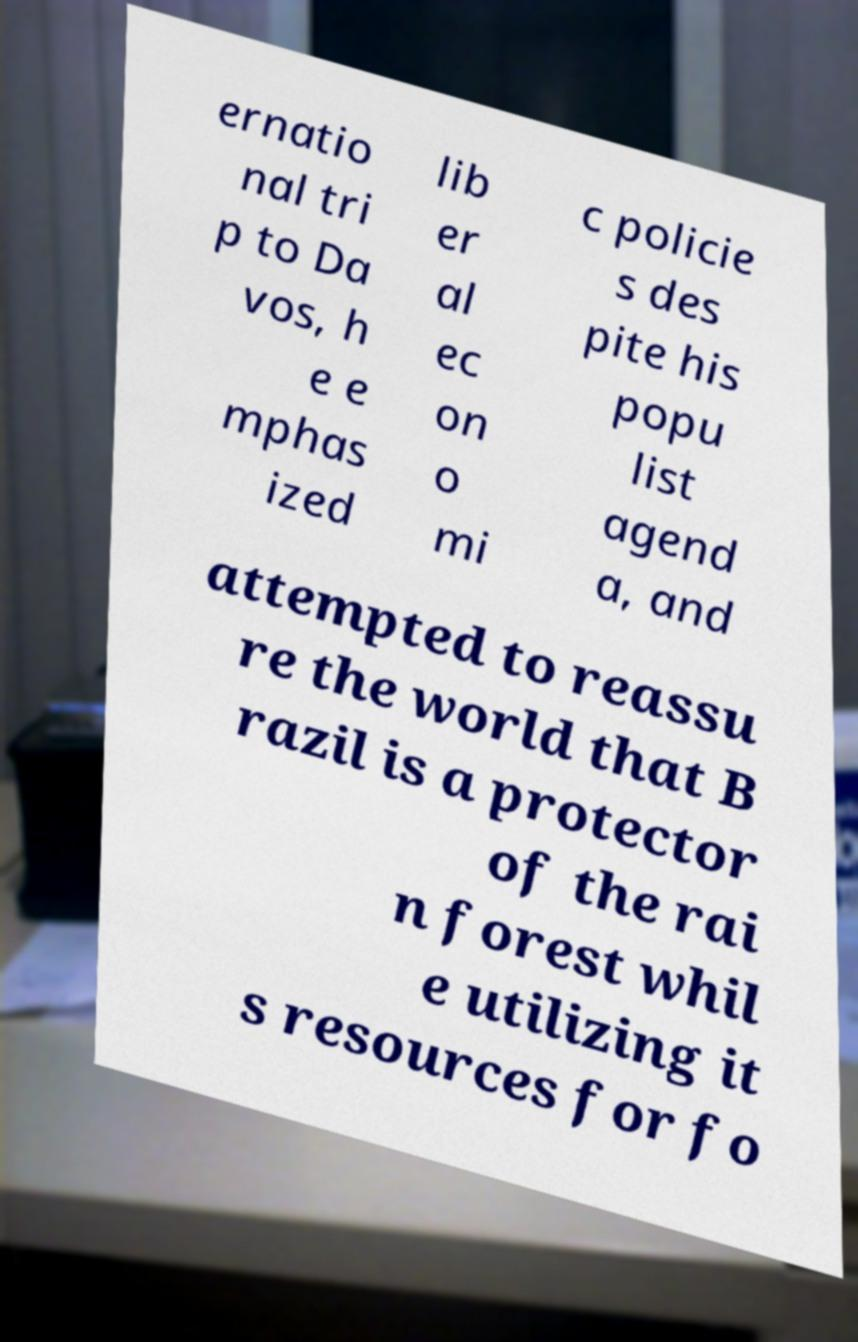Can you accurately transcribe the text from the provided image for me? ernatio nal tri p to Da vos, h e e mphas ized lib er al ec on o mi c policie s des pite his popu list agend a, and attempted to reassu re the world that B razil is a protector of the rai n forest whil e utilizing it s resources for fo 